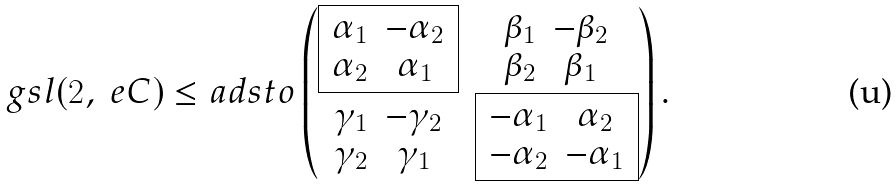<formula> <loc_0><loc_0><loc_500><loc_500>\ g s l ( 2 , \ e C ) \leq a d s t o \begin{pmatrix} \boxed { \begin{array} { c c } \alpha _ { 1 } & - \alpha _ { 2 } \\ \alpha _ { 2 } & \alpha _ { 1 } \end{array} } & \begin{array} { c c } \beta _ { 1 } & - \beta _ { 2 } \\ \beta _ { 2 } & \beta _ { 1 } \end{array} \\ \begin{array} { c c } \gamma _ { 1 } & - \gamma _ { 2 } \\ \gamma _ { 2 } & \gamma _ { 1 } \end{array} & \boxed { \begin{array} { c c } - \alpha _ { 1 } & \alpha _ { 2 } \\ - \alpha _ { 2 } & - \alpha _ { 1 } \end{array} } \end{pmatrix} .</formula> 